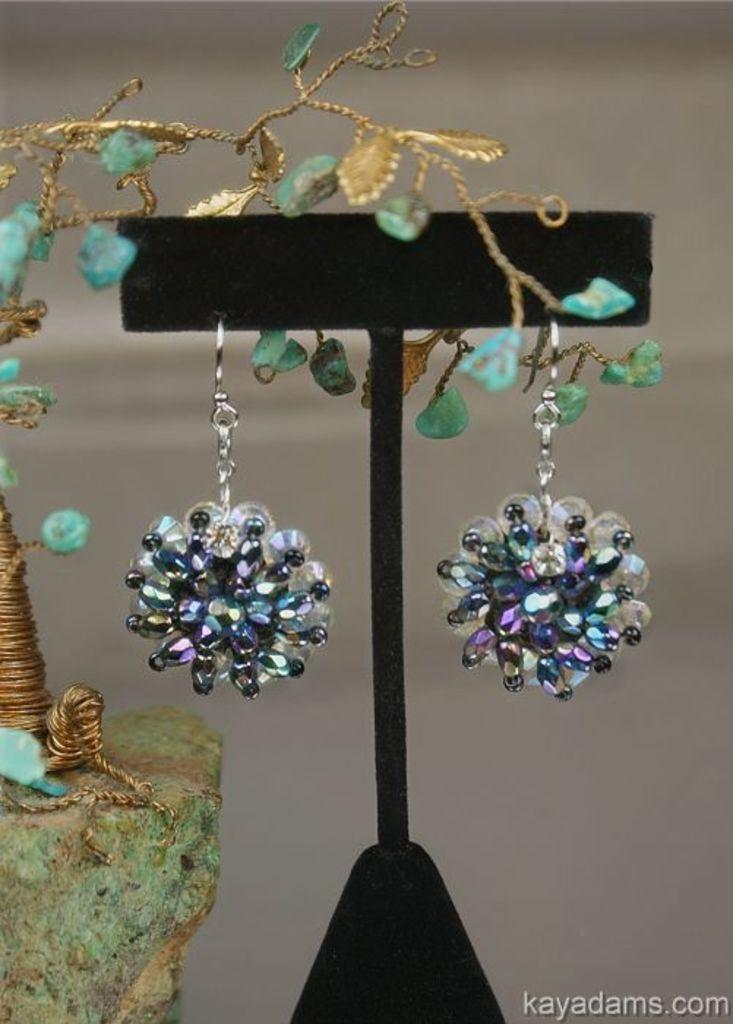What is the black object in the image? The black object in the image is not specified, but it is present. What type of accessory can be seen in the image? There are earrings in the image. Can you describe the background of the image? The background of the image is blurry. What other items are present in the image besides the black object and earrings? There are other unspecified stuff in the image. How many pets are visible in the image? There are no pets present in the image. What type of fang can be seen in the image? There is no fang present in the image. 